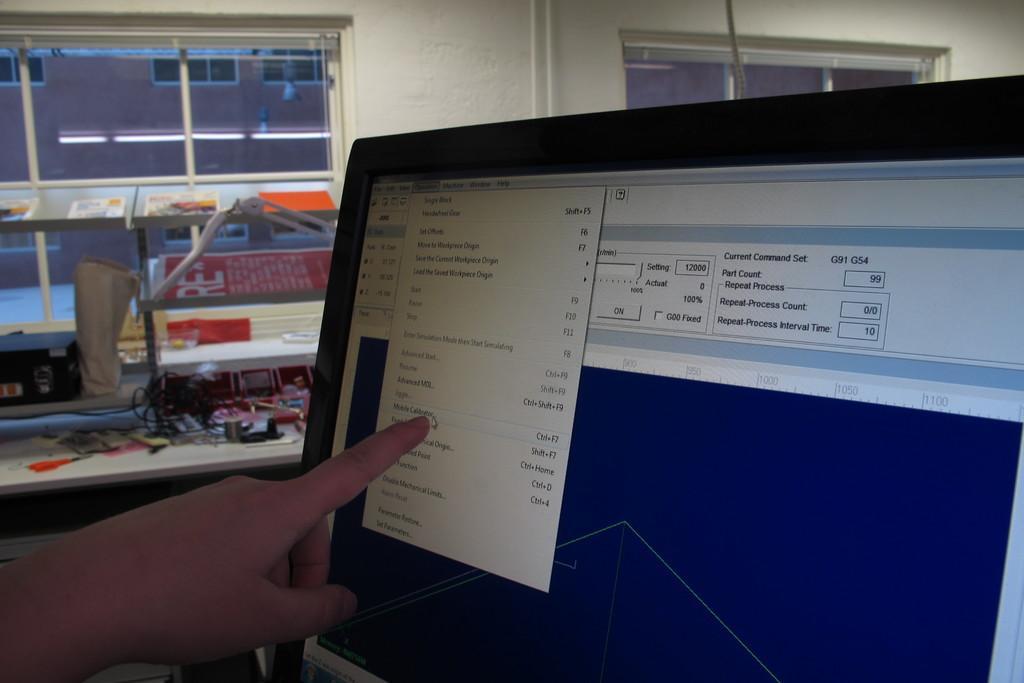Please provide a concise description of this image. In this picture there is a desktop in the right corner and there is a hand of a person pointing his index finger towards the desktop and there are some other objects in the background. 